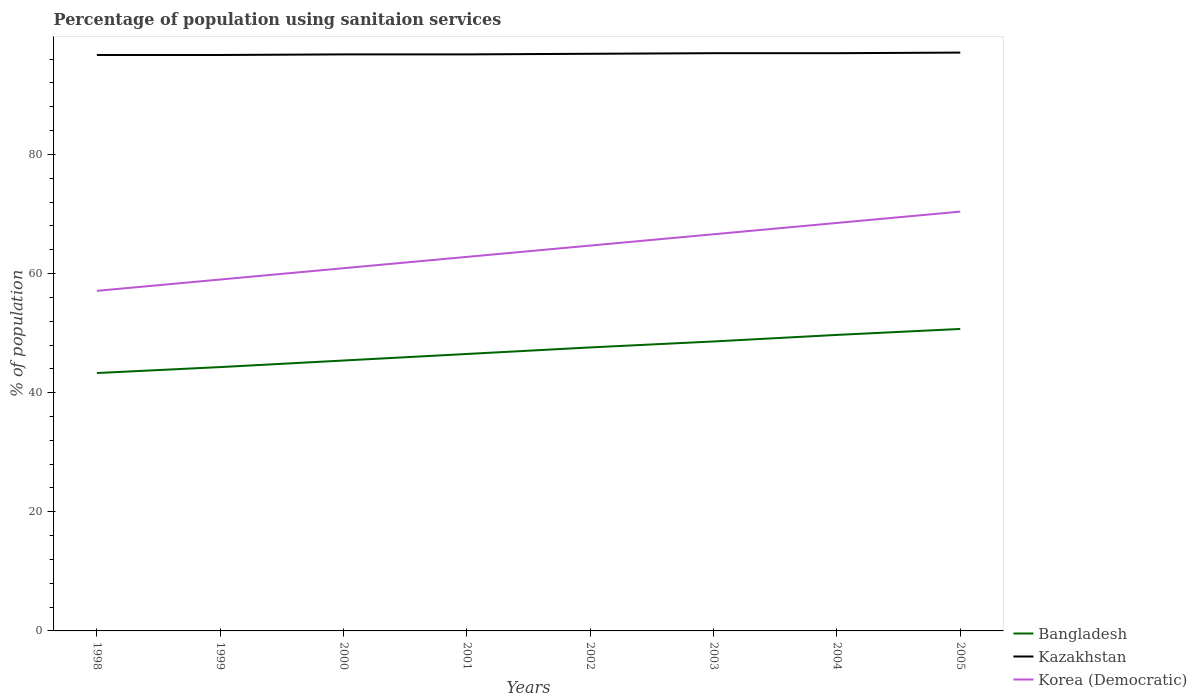How many different coloured lines are there?
Provide a succinct answer. 3. Does the line corresponding to Bangladesh intersect with the line corresponding to Kazakhstan?
Keep it short and to the point. No. Is the number of lines equal to the number of legend labels?
Keep it short and to the point. Yes. Across all years, what is the maximum percentage of population using sanitaion services in Korea (Democratic)?
Your answer should be compact. 57.1. What is the total percentage of population using sanitaion services in Korea (Democratic) in the graph?
Your answer should be very brief. -1.9. What is the difference between the highest and the second highest percentage of population using sanitaion services in Korea (Democratic)?
Make the answer very short. 13.3. How many lines are there?
Ensure brevity in your answer.  3. What is the difference between two consecutive major ticks on the Y-axis?
Keep it short and to the point. 20. Are the values on the major ticks of Y-axis written in scientific E-notation?
Give a very brief answer. No. How many legend labels are there?
Provide a succinct answer. 3. What is the title of the graph?
Provide a succinct answer. Percentage of population using sanitaion services. What is the label or title of the X-axis?
Provide a short and direct response. Years. What is the label or title of the Y-axis?
Provide a short and direct response. % of population. What is the % of population in Bangladesh in 1998?
Provide a succinct answer. 43.3. What is the % of population in Kazakhstan in 1998?
Provide a short and direct response. 96.7. What is the % of population of Korea (Democratic) in 1998?
Keep it short and to the point. 57.1. What is the % of population in Bangladesh in 1999?
Your response must be concise. 44.3. What is the % of population in Kazakhstan in 1999?
Give a very brief answer. 96.7. What is the % of population of Korea (Democratic) in 1999?
Your response must be concise. 59. What is the % of population of Bangladesh in 2000?
Your answer should be very brief. 45.4. What is the % of population in Kazakhstan in 2000?
Provide a succinct answer. 96.8. What is the % of population in Korea (Democratic) in 2000?
Your response must be concise. 60.9. What is the % of population in Bangladesh in 2001?
Offer a terse response. 46.5. What is the % of population in Kazakhstan in 2001?
Your response must be concise. 96.8. What is the % of population of Korea (Democratic) in 2001?
Provide a short and direct response. 62.8. What is the % of population of Bangladesh in 2002?
Ensure brevity in your answer.  47.6. What is the % of population of Kazakhstan in 2002?
Your answer should be very brief. 96.9. What is the % of population of Korea (Democratic) in 2002?
Ensure brevity in your answer.  64.7. What is the % of population in Bangladesh in 2003?
Make the answer very short. 48.6. What is the % of population in Kazakhstan in 2003?
Make the answer very short. 97. What is the % of population in Korea (Democratic) in 2003?
Your answer should be compact. 66.6. What is the % of population in Bangladesh in 2004?
Provide a short and direct response. 49.7. What is the % of population of Kazakhstan in 2004?
Provide a short and direct response. 97. What is the % of population of Korea (Democratic) in 2004?
Keep it short and to the point. 68.5. What is the % of population of Bangladesh in 2005?
Give a very brief answer. 50.7. What is the % of population in Kazakhstan in 2005?
Keep it short and to the point. 97.1. What is the % of population of Korea (Democratic) in 2005?
Make the answer very short. 70.4. Across all years, what is the maximum % of population in Bangladesh?
Provide a short and direct response. 50.7. Across all years, what is the maximum % of population of Kazakhstan?
Offer a terse response. 97.1. Across all years, what is the maximum % of population in Korea (Democratic)?
Provide a short and direct response. 70.4. Across all years, what is the minimum % of population of Bangladesh?
Make the answer very short. 43.3. Across all years, what is the minimum % of population in Kazakhstan?
Keep it short and to the point. 96.7. Across all years, what is the minimum % of population in Korea (Democratic)?
Your response must be concise. 57.1. What is the total % of population of Bangladesh in the graph?
Give a very brief answer. 376.1. What is the total % of population of Kazakhstan in the graph?
Your response must be concise. 775. What is the total % of population of Korea (Democratic) in the graph?
Your response must be concise. 510. What is the difference between the % of population in Bangladesh in 1998 and that in 1999?
Your answer should be compact. -1. What is the difference between the % of population of Kazakhstan in 1998 and that in 1999?
Your answer should be compact. 0. What is the difference between the % of population in Kazakhstan in 1998 and that in 2000?
Offer a very short reply. -0.1. What is the difference between the % of population in Kazakhstan in 1998 and that in 2001?
Give a very brief answer. -0.1. What is the difference between the % of population in Korea (Democratic) in 1998 and that in 2001?
Offer a very short reply. -5.7. What is the difference between the % of population in Bangladesh in 1998 and that in 2002?
Your answer should be compact. -4.3. What is the difference between the % of population of Kazakhstan in 1998 and that in 2002?
Make the answer very short. -0.2. What is the difference between the % of population in Korea (Democratic) in 1998 and that in 2003?
Make the answer very short. -9.5. What is the difference between the % of population of Bangladesh in 1998 and that in 2004?
Offer a terse response. -6.4. What is the difference between the % of population in Kazakhstan in 1998 and that in 2004?
Provide a succinct answer. -0.3. What is the difference between the % of population of Korea (Democratic) in 1998 and that in 2005?
Keep it short and to the point. -13.3. What is the difference between the % of population in Bangladesh in 1999 and that in 2000?
Your answer should be very brief. -1.1. What is the difference between the % of population of Kazakhstan in 1999 and that in 2000?
Offer a very short reply. -0.1. What is the difference between the % of population of Korea (Democratic) in 1999 and that in 2000?
Offer a terse response. -1.9. What is the difference between the % of population in Bangladesh in 1999 and that in 2001?
Offer a terse response. -2.2. What is the difference between the % of population in Kazakhstan in 1999 and that in 2002?
Your response must be concise. -0.2. What is the difference between the % of population in Korea (Democratic) in 1999 and that in 2002?
Your response must be concise. -5.7. What is the difference between the % of population in Bangladesh in 1999 and that in 2003?
Make the answer very short. -4.3. What is the difference between the % of population of Kazakhstan in 1999 and that in 2003?
Your response must be concise. -0.3. What is the difference between the % of population in Kazakhstan in 1999 and that in 2004?
Give a very brief answer. -0.3. What is the difference between the % of population of Korea (Democratic) in 1999 and that in 2004?
Your answer should be very brief. -9.5. What is the difference between the % of population of Kazakhstan in 2000 and that in 2001?
Your answer should be very brief. 0. What is the difference between the % of population of Kazakhstan in 2000 and that in 2002?
Ensure brevity in your answer.  -0.1. What is the difference between the % of population of Korea (Democratic) in 2000 and that in 2003?
Offer a terse response. -5.7. What is the difference between the % of population in Korea (Democratic) in 2000 and that in 2004?
Your answer should be very brief. -7.6. What is the difference between the % of population of Korea (Democratic) in 2001 and that in 2003?
Keep it short and to the point. -3.8. What is the difference between the % of population in Kazakhstan in 2001 and that in 2004?
Make the answer very short. -0.2. What is the difference between the % of population in Korea (Democratic) in 2001 and that in 2004?
Your answer should be compact. -5.7. What is the difference between the % of population in Kazakhstan in 2001 and that in 2005?
Offer a very short reply. -0.3. What is the difference between the % of population of Korea (Democratic) in 2001 and that in 2005?
Your answer should be compact. -7.6. What is the difference between the % of population in Korea (Democratic) in 2002 and that in 2003?
Provide a succinct answer. -1.9. What is the difference between the % of population in Bangladesh in 2002 and that in 2004?
Your answer should be very brief. -2.1. What is the difference between the % of population of Kazakhstan in 2002 and that in 2004?
Your response must be concise. -0.1. What is the difference between the % of population in Bangladesh in 2002 and that in 2005?
Offer a terse response. -3.1. What is the difference between the % of population of Kazakhstan in 2002 and that in 2005?
Your answer should be very brief. -0.2. What is the difference between the % of population of Kazakhstan in 2003 and that in 2004?
Your answer should be compact. 0. What is the difference between the % of population in Korea (Democratic) in 2003 and that in 2004?
Provide a short and direct response. -1.9. What is the difference between the % of population in Korea (Democratic) in 2003 and that in 2005?
Make the answer very short. -3.8. What is the difference between the % of population in Korea (Democratic) in 2004 and that in 2005?
Your answer should be compact. -1.9. What is the difference between the % of population in Bangladesh in 1998 and the % of population in Kazakhstan in 1999?
Your answer should be very brief. -53.4. What is the difference between the % of population in Bangladesh in 1998 and the % of population in Korea (Democratic) in 1999?
Offer a very short reply. -15.7. What is the difference between the % of population in Kazakhstan in 1998 and the % of population in Korea (Democratic) in 1999?
Your answer should be very brief. 37.7. What is the difference between the % of population of Bangladesh in 1998 and the % of population of Kazakhstan in 2000?
Your answer should be compact. -53.5. What is the difference between the % of population in Bangladesh in 1998 and the % of population in Korea (Democratic) in 2000?
Provide a short and direct response. -17.6. What is the difference between the % of population in Kazakhstan in 1998 and the % of population in Korea (Democratic) in 2000?
Ensure brevity in your answer.  35.8. What is the difference between the % of population in Bangladesh in 1998 and the % of population in Kazakhstan in 2001?
Offer a very short reply. -53.5. What is the difference between the % of population in Bangladesh in 1998 and the % of population in Korea (Democratic) in 2001?
Give a very brief answer. -19.5. What is the difference between the % of population in Kazakhstan in 1998 and the % of population in Korea (Democratic) in 2001?
Give a very brief answer. 33.9. What is the difference between the % of population of Bangladesh in 1998 and the % of population of Kazakhstan in 2002?
Provide a short and direct response. -53.6. What is the difference between the % of population in Bangladesh in 1998 and the % of population in Korea (Democratic) in 2002?
Offer a very short reply. -21.4. What is the difference between the % of population of Bangladesh in 1998 and the % of population of Kazakhstan in 2003?
Your answer should be compact. -53.7. What is the difference between the % of population in Bangladesh in 1998 and the % of population in Korea (Democratic) in 2003?
Offer a terse response. -23.3. What is the difference between the % of population in Kazakhstan in 1998 and the % of population in Korea (Democratic) in 2003?
Ensure brevity in your answer.  30.1. What is the difference between the % of population in Bangladesh in 1998 and the % of population in Kazakhstan in 2004?
Ensure brevity in your answer.  -53.7. What is the difference between the % of population in Bangladesh in 1998 and the % of population in Korea (Democratic) in 2004?
Offer a very short reply. -25.2. What is the difference between the % of population of Kazakhstan in 1998 and the % of population of Korea (Democratic) in 2004?
Your answer should be compact. 28.2. What is the difference between the % of population in Bangladesh in 1998 and the % of population in Kazakhstan in 2005?
Ensure brevity in your answer.  -53.8. What is the difference between the % of population in Bangladesh in 1998 and the % of population in Korea (Democratic) in 2005?
Make the answer very short. -27.1. What is the difference between the % of population of Kazakhstan in 1998 and the % of population of Korea (Democratic) in 2005?
Give a very brief answer. 26.3. What is the difference between the % of population of Bangladesh in 1999 and the % of population of Kazakhstan in 2000?
Give a very brief answer. -52.5. What is the difference between the % of population in Bangladesh in 1999 and the % of population in Korea (Democratic) in 2000?
Provide a succinct answer. -16.6. What is the difference between the % of population in Kazakhstan in 1999 and the % of population in Korea (Democratic) in 2000?
Your answer should be compact. 35.8. What is the difference between the % of population in Bangladesh in 1999 and the % of population in Kazakhstan in 2001?
Your response must be concise. -52.5. What is the difference between the % of population in Bangladesh in 1999 and the % of population in Korea (Democratic) in 2001?
Give a very brief answer. -18.5. What is the difference between the % of population in Kazakhstan in 1999 and the % of population in Korea (Democratic) in 2001?
Ensure brevity in your answer.  33.9. What is the difference between the % of population of Bangladesh in 1999 and the % of population of Kazakhstan in 2002?
Provide a short and direct response. -52.6. What is the difference between the % of population in Bangladesh in 1999 and the % of population in Korea (Democratic) in 2002?
Your answer should be compact. -20.4. What is the difference between the % of population of Kazakhstan in 1999 and the % of population of Korea (Democratic) in 2002?
Provide a succinct answer. 32. What is the difference between the % of population of Bangladesh in 1999 and the % of population of Kazakhstan in 2003?
Keep it short and to the point. -52.7. What is the difference between the % of population of Bangladesh in 1999 and the % of population of Korea (Democratic) in 2003?
Offer a terse response. -22.3. What is the difference between the % of population in Kazakhstan in 1999 and the % of population in Korea (Democratic) in 2003?
Keep it short and to the point. 30.1. What is the difference between the % of population of Bangladesh in 1999 and the % of population of Kazakhstan in 2004?
Provide a succinct answer. -52.7. What is the difference between the % of population of Bangladesh in 1999 and the % of population of Korea (Democratic) in 2004?
Keep it short and to the point. -24.2. What is the difference between the % of population of Kazakhstan in 1999 and the % of population of Korea (Democratic) in 2004?
Ensure brevity in your answer.  28.2. What is the difference between the % of population of Bangladesh in 1999 and the % of population of Kazakhstan in 2005?
Offer a very short reply. -52.8. What is the difference between the % of population in Bangladesh in 1999 and the % of population in Korea (Democratic) in 2005?
Your answer should be very brief. -26.1. What is the difference between the % of population of Kazakhstan in 1999 and the % of population of Korea (Democratic) in 2005?
Give a very brief answer. 26.3. What is the difference between the % of population of Bangladesh in 2000 and the % of population of Kazakhstan in 2001?
Keep it short and to the point. -51.4. What is the difference between the % of population in Bangladesh in 2000 and the % of population in Korea (Democratic) in 2001?
Your answer should be compact. -17.4. What is the difference between the % of population in Bangladesh in 2000 and the % of population in Kazakhstan in 2002?
Give a very brief answer. -51.5. What is the difference between the % of population in Bangladesh in 2000 and the % of population in Korea (Democratic) in 2002?
Your response must be concise. -19.3. What is the difference between the % of population in Kazakhstan in 2000 and the % of population in Korea (Democratic) in 2002?
Your answer should be compact. 32.1. What is the difference between the % of population of Bangladesh in 2000 and the % of population of Kazakhstan in 2003?
Your answer should be compact. -51.6. What is the difference between the % of population of Bangladesh in 2000 and the % of population of Korea (Democratic) in 2003?
Your answer should be compact. -21.2. What is the difference between the % of population of Kazakhstan in 2000 and the % of population of Korea (Democratic) in 2003?
Keep it short and to the point. 30.2. What is the difference between the % of population in Bangladesh in 2000 and the % of population in Kazakhstan in 2004?
Keep it short and to the point. -51.6. What is the difference between the % of population of Bangladesh in 2000 and the % of population of Korea (Democratic) in 2004?
Provide a succinct answer. -23.1. What is the difference between the % of population of Kazakhstan in 2000 and the % of population of Korea (Democratic) in 2004?
Give a very brief answer. 28.3. What is the difference between the % of population in Bangladesh in 2000 and the % of population in Kazakhstan in 2005?
Your answer should be compact. -51.7. What is the difference between the % of population in Bangladesh in 2000 and the % of population in Korea (Democratic) in 2005?
Make the answer very short. -25. What is the difference between the % of population of Kazakhstan in 2000 and the % of population of Korea (Democratic) in 2005?
Provide a short and direct response. 26.4. What is the difference between the % of population in Bangladesh in 2001 and the % of population in Kazakhstan in 2002?
Provide a short and direct response. -50.4. What is the difference between the % of population of Bangladesh in 2001 and the % of population of Korea (Democratic) in 2002?
Keep it short and to the point. -18.2. What is the difference between the % of population in Kazakhstan in 2001 and the % of population in Korea (Democratic) in 2002?
Keep it short and to the point. 32.1. What is the difference between the % of population of Bangladesh in 2001 and the % of population of Kazakhstan in 2003?
Make the answer very short. -50.5. What is the difference between the % of population of Bangladesh in 2001 and the % of population of Korea (Democratic) in 2003?
Offer a very short reply. -20.1. What is the difference between the % of population in Kazakhstan in 2001 and the % of population in Korea (Democratic) in 2003?
Offer a terse response. 30.2. What is the difference between the % of population in Bangladesh in 2001 and the % of population in Kazakhstan in 2004?
Keep it short and to the point. -50.5. What is the difference between the % of population in Kazakhstan in 2001 and the % of population in Korea (Democratic) in 2004?
Your response must be concise. 28.3. What is the difference between the % of population in Bangladesh in 2001 and the % of population in Kazakhstan in 2005?
Your answer should be very brief. -50.6. What is the difference between the % of population in Bangladesh in 2001 and the % of population in Korea (Democratic) in 2005?
Your response must be concise. -23.9. What is the difference between the % of population in Kazakhstan in 2001 and the % of population in Korea (Democratic) in 2005?
Make the answer very short. 26.4. What is the difference between the % of population of Bangladesh in 2002 and the % of population of Kazakhstan in 2003?
Offer a terse response. -49.4. What is the difference between the % of population of Kazakhstan in 2002 and the % of population of Korea (Democratic) in 2003?
Ensure brevity in your answer.  30.3. What is the difference between the % of population in Bangladesh in 2002 and the % of population in Kazakhstan in 2004?
Your response must be concise. -49.4. What is the difference between the % of population of Bangladesh in 2002 and the % of population of Korea (Democratic) in 2004?
Your response must be concise. -20.9. What is the difference between the % of population in Kazakhstan in 2002 and the % of population in Korea (Democratic) in 2004?
Offer a very short reply. 28.4. What is the difference between the % of population of Bangladesh in 2002 and the % of population of Kazakhstan in 2005?
Provide a succinct answer. -49.5. What is the difference between the % of population of Bangladesh in 2002 and the % of population of Korea (Democratic) in 2005?
Your answer should be compact. -22.8. What is the difference between the % of population of Bangladesh in 2003 and the % of population of Kazakhstan in 2004?
Offer a terse response. -48.4. What is the difference between the % of population in Bangladesh in 2003 and the % of population in Korea (Democratic) in 2004?
Make the answer very short. -19.9. What is the difference between the % of population of Bangladesh in 2003 and the % of population of Kazakhstan in 2005?
Your response must be concise. -48.5. What is the difference between the % of population in Bangladesh in 2003 and the % of population in Korea (Democratic) in 2005?
Give a very brief answer. -21.8. What is the difference between the % of population in Kazakhstan in 2003 and the % of population in Korea (Democratic) in 2005?
Provide a short and direct response. 26.6. What is the difference between the % of population in Bangladesh in 2004 and the % of population in Kazakhstan in 2005?
Your answer should be compact. -47.4. What is the difference between the % of population in Bangladesh in 2004 and the % of population in Korea (Democratic) in 2005?
Offer a very short reply. -20.7. What is the difference between the % of population of Kazakhstan in 2004 and the % of population of Korea (Democratic) in 2005?
Your answer should be very brief. 26.6. What is the average % of population of Bangladesh per year?
Provide a short and direct response. 47.01. What is the average % of population in Kazakhstan per year?
Keep it short and to the point. 96.88. What is the average % of population in Korea (Democratic) per year?
Keep it short and to the point. 63.75. In the year 1998, what is the difference between the % of population in Bangladesh and % of population in Kazakhstan?
Give a very brief answer. -53.4. In the year 1998, what is the difference between the % of population of Bangladesh and % of population of Korea (Democratic)?
Your response must be concise. -13.8. In the year 1998, what is the difference between the % of population in Kazakhstan and % of population in Korea (Democratic)?
Your response must be concise. 39.6. In the year 1999, what is the difference between the % of population of Bangladesh and % of population of Kazakhstan?
Keep it short and to the point. -52.4. In the year 1999, what is the difference between the % of population in Bangladesh and % of population in Korea (Democratic)?
Provide a short and direct response. -14.7. In the year 1999, what is the difference between the % of population in Kazakhstan and % of population in Korea (Democratic)?
Provide a succinct answer. 37.7. In the year 2000, what is the difference between the % of population of Bangladesh and % of population of Kazakhstan?
Provide a short and direct response. -51.4. In the year 2000, what is the difference between the % of population in Bangladesh and % of population in Korea (Democratic)?
Make the answer very short. -15.5. In the year 2000, what is the difference between the % of population in Kazakhstan and % of population in Korea (Democratic)?
Provide a succinct answer. 35.9. In the year 2001, what is the difference between the % of population in Bangladesh and % of population in Kazakhstan?
Offer a terse response. -50.3. In the year 2001, what is the difference between the % of population in Bangladesh and % of population in Korea (Democratic)?
Provide a succinct answer. -16.3. In the year 2002, what is the difference between the % of population in Bangladesh and % of population in Kazakhstan?
Your response must be concise. -49.3. In the year 2002, what is the difference between the % of population in Bangladesh and % of population in Korea (Democratic)?
Ensure brevity in your answer.  -17.1. In the year 2002, what is the difference between the % of population of Kazakhstan and % of population of Korea (Democratic)?
Your response must be concise. 32.2. In the year 2003, what is the difference between the % of population in Bangladesh and % of population in Kazakhstan?
Provide a succinct answer. -48.4. In the year 2003, what is the difference between the % of population in Kazakhstan and % of population in Korea (Democratic)?
Your answer should be compact. 30.4. In the year 2004, what is the difference between the % of population of Bangladesh and % of population of Kazakhstan?
Your answer should be compact. -47.3. In the year 2004, what is the difference between the % of population in Bangladesh and % of population in Korea (Democratic)?
Your answer should be very brief. -18.8. In the year 2005, what is the difference between the % of population in Bangladesh and % of population in Kazakhstan?
Provide a short and direct response. -46.4. In the year 2005, what is the difference between the % of population in Bangladesh and % of population in Korea (Democratic)?
Your answer should be compact. -19.7. In the year 2005, what is the difference between the % of population in Kazakhstan and % of population in Korea (Democratic)?
Your answer should be very brief. 26.7. What is the ratio of the % of population in Bangladesh in 1998 to that in 1999?
Make the answer very short. 0.98. What is the ratio of the % of population in Korea (Democratic) in 1998 to that in 1999?
Provide a short and direct response. 0.97. What is the ratio of the % of population of Bangladesh in 1998 to that in 2000?
Offer a very short reply. 0.95. What is the ratio of the % of population in Kazakhstan in 1998 to that in 2000?
Give a very brief answer. 1. What is the ratio of the % of population in Korea (Democratic) in 1998 to that in 2000?
Give a very brief answer. 0.94. What is the ratio of the % of population of Bangladesh in 1998 to that in 2001?
Your response must be concise. 0.93. What is the ratio of the % of population of Kazakhstan in 1998 to that in 2001?
Provide a succinct answer. 1. What is the ratio of the % of population of Korea (Democratic) in 1998 to that in 2001?
Ensure brevity in your answer.  0.91. What is the ratio of the % of population of Bangladesh in 1998 to that in 2002?
Make the answer very short. 0.91. What is the ratio of the % of population of Korea (Democratic) in 1998 to that in 2002?
Ensure brevity in your answer.  0.88. What is the ratio of the % of population in Bangladesh in 1998 to that in 2003?
Give a very brief answer. 0.89. What is the ratio of the % of population in Kazakhstan in 1998 to that in 2003?
Provide a succinct answer. 1. What is the ratio of the % of population of Korea (Democratic) in 1998 to that in 2003?
Your response must be concise. 0.86. What is the ratio of the % of population in Bangladesh in 1998 to that in 2004?
Make the answer very short. 0.87. What is the ratio of the % of population in Korea (Democratic) in 1998 to that in 2004?
Offer a very short reply. 0.83. What is the ratio of the % of population in Bangladesh in 1998 to that in 2005?
Provide a short and direct response. 0.85. What is the ratio of the % of population of Korea (Democratic) in 1998 to that in 2005?
Your answer should be compact. 0.81. What is the ratio of the % of population in Bangladesh in 1999 to that in 2000?
Ensure brevity in your answer.  0.98. What is the ratio of the % of population of Kazakhstan in 1999 to that in 2000?
Your response must be concise. 1. What is the ratio of the % of population of Korea (Democratic) in 1999 to that in 2000?
Give a very brief answer. 0.97. What is the ratio of the % of population in Bangladesh in 1999 to that in 2001?
Provide a succinct answer. 0.95. What is the ratio of the % of population in Kazakhstan in 1999 to that in 2001?
Ensure brevity in your answer.  1. What is the ratio of the % of population in Korea (Democratic) in 1999 to that in 2001?
Ensure brevity in your answer.  0.94. What is the ratio of the % of population in Bangladesh in 1999 to that in 2002?
Your answer should be compact. 0.93. What is the ratio of the % of population of Kazakhstan in 1999 to that in 2002?
Your answer should be compact. 1. What is the ratio of the % of population of Korea (Democratic) in 1999 to that in 2002?
Ensure brevity in your answer.  0.91. What is the ratio of the % of population in Bangladesh in 1999 to that in 2003?
Offer a very short reply. 0.91. What is the ratio of the % of population of Korea (Democratic) in 1999 to that in 2003?
Offer a very short reply. 0.89. What is the ratio of the % of population of Bangladesh in 1999 to that in 2004?
Provide a succinct answer. 0.89. What is the ratio of the % of population of Kazakhstan in 1999 to that in 2004?
Make the answer very short. 1. What is the ratio of the % of population in Korea (Democratic) in 1999 to that in 2004?
Provide a succinct answer. 0.86. What is the ratio of the % of population in Bangladesh in 1999 to that in 2005?
Provide a succinct answer. 0.87. What is the ratio of the % of population of Korea (Democratic) in 1999 to that in 2005?
Provide a short and direct response. 0.84. What is the ratio of the % of population in Bangladesh in 2000 to that in 2001?
Give a very brief answer. 0.98. What is the ratio of the % of population in Kazakhstan in 2000 to that in 2001?
Your answer should be compact. 1. What is the ratio of the % of population of Korea (Democratic) in 2000 to that in 2001?
Provide a succinct answer. 0.97. What is the ratio of the % of population in Bangladesh in 2000 to that in 2002?
Offer a terse response. 0.95. What is the ratio of the % of population in Korea (Democratic) in 2000 to that in 2002?
Keep it short and to the point. 0.94. What is the ratio of the % of population of Bangladesh in 2000 to that in 2003?
Your answer should be compact. 0.93. What is the ratio of the % of population of Kazakhstan in 2000 to that in 2003?
Your answer should be very brief. 1. What is the ratio of the % of population of Korea (Democratic) in 2000 to that in 2003?
Your answer should be compact. 0.91. What is the ratio of the % of population of Bangladesh in 2000 to that in 2004?
Make the answer very short. 0.91. What is the ratio of the % of population in Korea (Democratic) in 2000 to that in 2004?
Provide a short and direct response. 0.89. What is the ratio of the % of population in Bangladesh in 2000 to that in 2005?
Offer a terse response. 0.9. What is the ratio of the % of population of Kazakhstan in 2000 to that in 2005?
Keep it short and to the point. 1. What is the ratio of the % of population in Korea (Democratic) in 2000 to that in 2005?
Offer a very short reply. 0.87. What is the ratio of the % of population in Bangladesh in 2001 to that in 2002?
Offer a terse response. 0.98. What is the ratio of the % of population in Korea (Democratic) in 2001 to that in 2002?
Provide a short and direct response. 0.97. What is the ratio of the % of population in Bangladesh in 2001 to that in 2003?
Offer a terse response. 0.96. What is the ratio of the % of population in Kazakhstan in 2001 to that in 2003?
Make the answer very short. 1. What is the ratio of the % of population of Korea (Democratic) in 2001 to that in 2003?
Offer a very short reply. 0.94. What is the ratio of the % of population in Bangladesh in 2001 to that in 2004?
Provide a short and direct response. 0.94. What is the ratio of the % of population of Kazakhstan in 2001 to that in 2004?
Your response must be concise. 1. What is the ratio of the % of population of Korea (Democratic) in 2001 to that in 2004?
Offer a terse response. 0.92. What is the ratio of the % of population in Bangladesh in 2001 to that in 2005?
Offer a terse response. 0.92. What is the ratio of the % of population in Korea (Democratic) in 2001 to that in 2005?
Your answer should be compact. 0.89. What is the ratio of the % of population in Bangladesh in 2002 to that in 2003?
Provide a succinct answer. 0.98. What is the ratio of the % of population in Korea (Democratic) in 2002 to that in 2003?
Give a very brief answer. 0.97. What is the ratio of the % of population in Bangladesh in 2002 to that in 2004?
Your answer should be very brief. 0.96. What is the ratio of the % of population of Korea (Democratic) in 2002 to that in 2004?
Provide a short and direct response. 0.94. What is the ratio of the % of population of Bangladesh in 2002 to that in 2005?
Give a very brief answer. 0.94. What is the ratio of the % of population in Kazakhstan in 2002 to that in 2005?
Provide a succinct answer. 1. What is the ratio of the % of population in Korea (Democratic) in 2002 to that in 2005?
Ensure brevity in your answer.  0.92. What is the ratio of the % of population of Bangladesh in 2003 to that in 2004?
Ensure brevity in your answer.  0.98. What is the ratio of the % of population of Korea (Democratic) in 2003 to that in 2004?
Your response must be concise. 0.97. What is the ratio of the % of population of Bangladesh in 2003 to that in 2005?
Provide a succinct answer. 0.96. What is the ratio of the % of population in Korea (Democratic) in 2003 to that in 2005?
Keep it short and to the point. 0.95. What is the ratio of the % of population in Bangladesh in 2004 to that in 2005?
Keep it short and to the point. 0.98. What is the ratio of the % of population of Kazakhstan in 2004 to that in 2005?
Your response must be concise. 1. What is the difference between the highest and the second highest % of population of Korea (Democratic)?
Your answer should be compact. 1.9. What is the difference between the highest and the lowest % of population of Bangladesh?
Provide a succinct answer. 7.4. What is the difference between the highest and the lowest % of population in Korea (Democratic)?
Give a very brief answer. 13.3. 